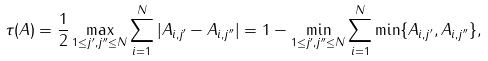<formula> <loc_0><loc_0><loc_500><loc_500>\tau ( A ) = \frac { 1 } { 2 } \max _ { 1 \leq j ^ { \prime } , j ^ { \prime \prime } \leq N } \sum _ { i = 1 } ^ { N } | A _ { i , j ^ { \prime } } - A _ { i , j ^ { \prime \prime } } | = 1 - \min _ { 1 \leq j ^ { \prime } , j ^ { \prime \prime } \leq N } \sum _ { i = 1 } ^ { N } \min \{ A _ { i , j ^ { \prime } } , A _ { i , j ^ { \prime \prime } } \} ,</formula> 